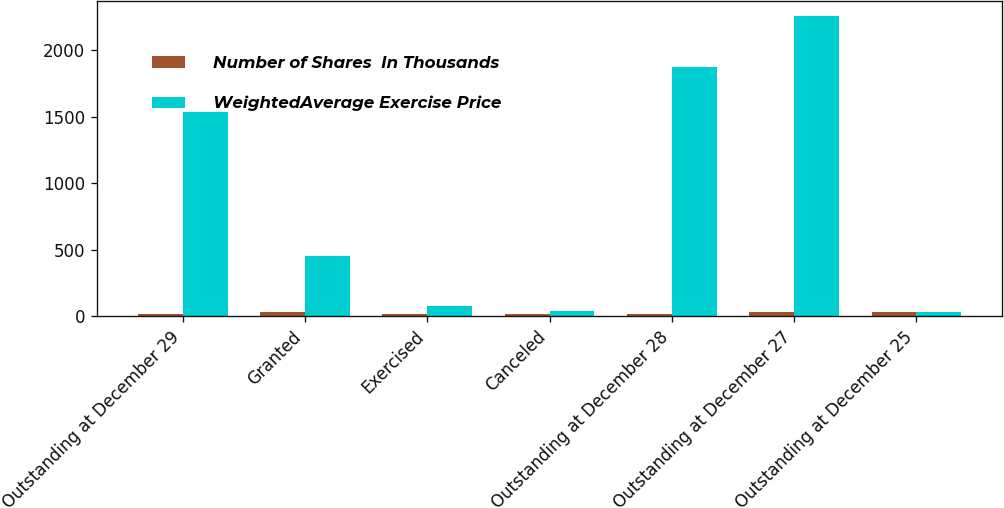Convert chart. <chart><loc_0><loc_0><loc_500><loc_500><stacked_bar_chart><ecel><fcel>Outstanding at December 29<fcel>Granted<fcel>Exercised<fcel>Canceled<fcel>Outstanding at December 28<fcel>Outstanding at December 27<fcel>Outstanding at December 25<nl><fcel>Number of Shares  In Thousands<fcel>15.45<fcel>29.61<fcel>14.15<fcel>16.58<fcel>18.9<fcel>28.42<fcel>32.12<nl><fcel>WeightedAverage Exercise Price<fcel>1535<fcel>453<fcel>74<fcel>40<fcel>1874<fcel>2257<fcel>32.12<nl></chart> 